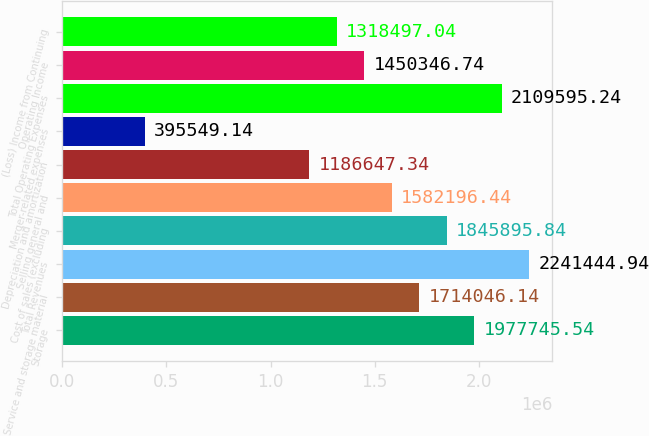Convert chart. <chart><loc_0><loc_0><loc_500><loc_500><bar_chart><fcel>Storage<fcel>Service and storage material<fcel>Total Revenues<fcel>Cost of sales (excluding<fcel>Selling general and<fcel>Depreciation and amortization<fcel>Merger-related expenses<fcel>Total Operating Expenses<fcel>Operating Income<fcel>(Loss) Income from Continuing<nl><fcel>1.97775e+06<fcel>1.71405e+06<fcel>2.24144e+06<fcel>1.8459e+06<fcel>1.5822e+06<fcel>1.18665e+06<fcel>395549<fcel>2.1096e+06<fcel>1.45035e+06<fcel>1.3185e+06<nl></chart> 